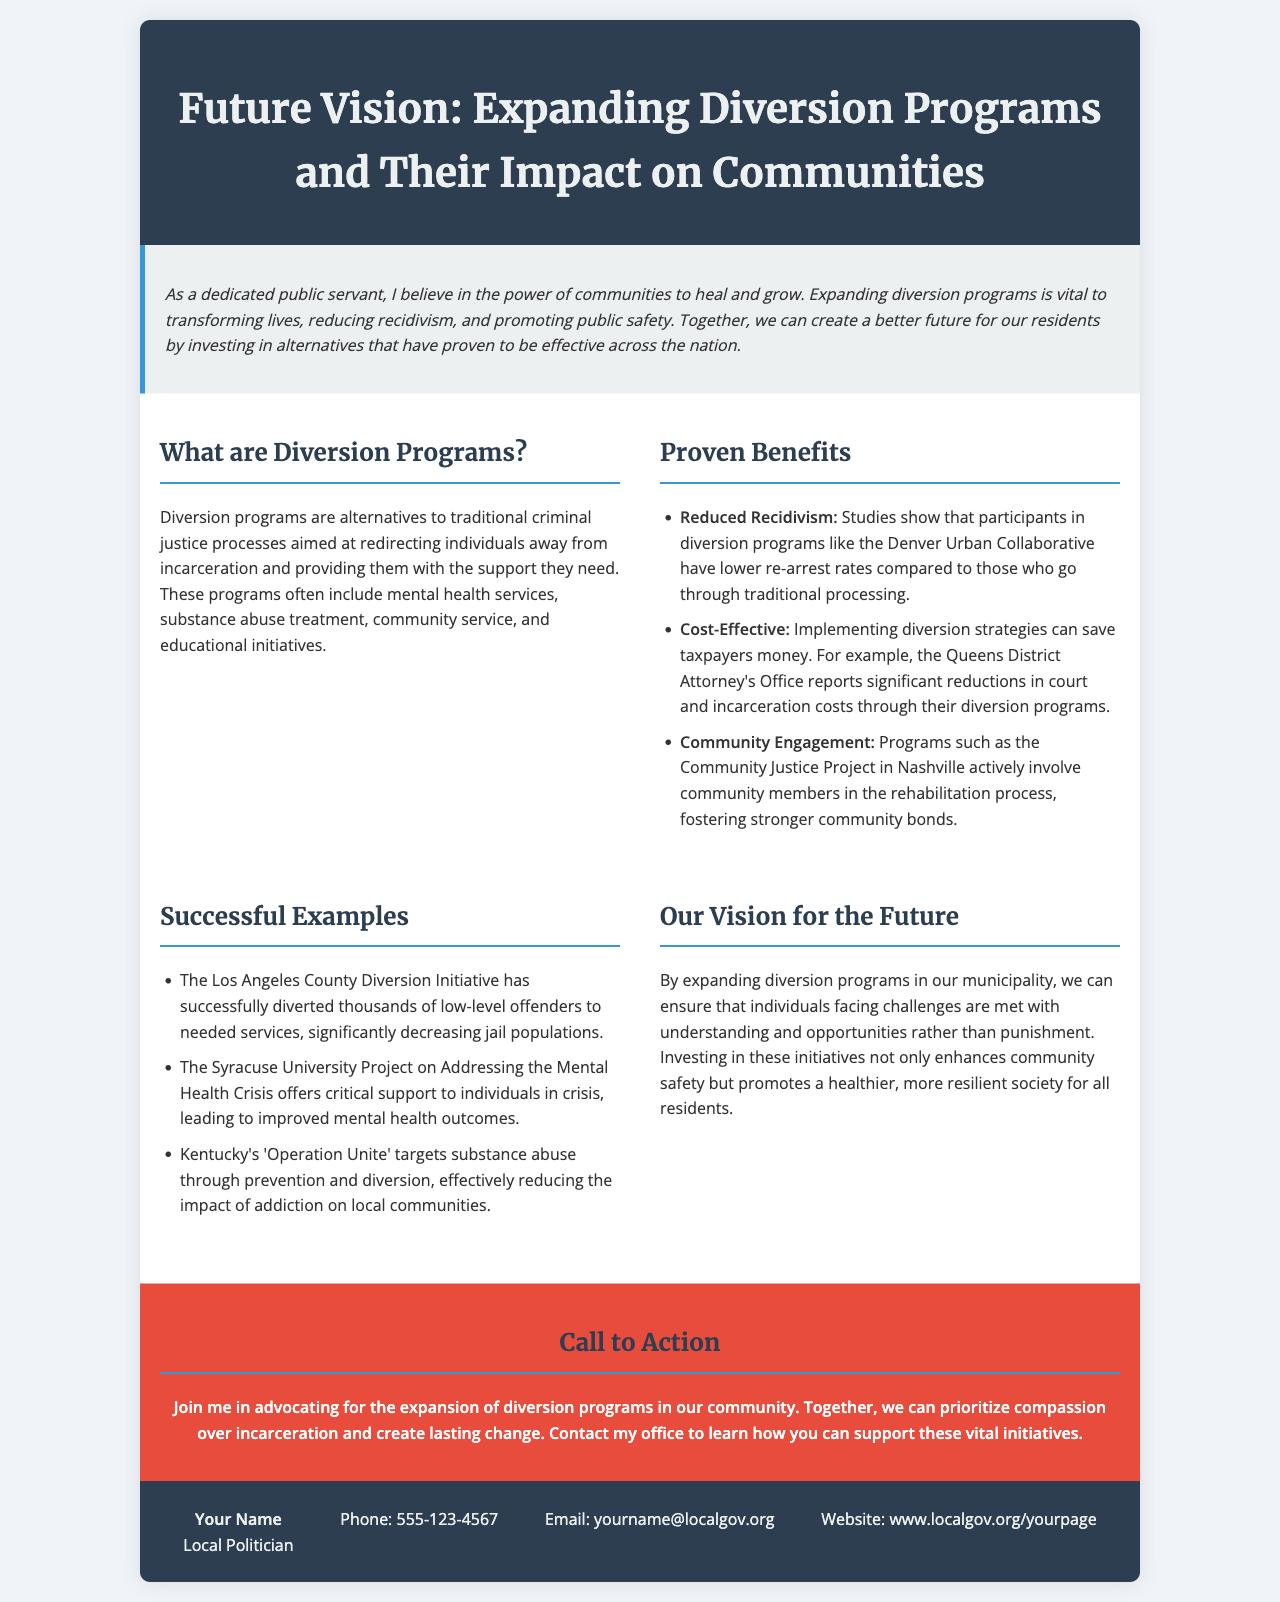What are diversion programs? Diversion programs are alternatives to traditional criminal justice processes aimed at redirecting individuals away from incarceration and providing them with support.
Answer: Alternatives to incarceration What is one proven benefit of diversion programs? One proven benefit of diversion programs mentioned is reduced recidivism, as studies show lower re-arrest rates for participants.
Answer: Reduced recidivism Which initiative successfully diverted low-level offenders? The initiative that successfully diverted low-level offenders is the Los Angeles County Diversion Initiative.
Answer: Los Angeles County Diversion Initiative What organization reports cost savings from diversion programs? The organization that reports significant cost reductions from diversion programs is the Queens District Attorney's Office.
Answer: Queens District Attorney's Office What is the main objective of expanding diversion programs according to the vision presented? The main objective of expanding diversion programs is to meet individuals facing challenges with understanding and opportunities rather than punishment.
Answer: Understanding and opportunities How can community members get involved according to the call to action? Community members can get involved by contacting the office to learn how to support these vital initiatives.
Answer: Contact my office What is the printed contact phone number? The printed contact phone number listed in the brochure is 555-123-4567.
Answer: 555-123-4567 What percentage of community engagement is promoted by the Community Justice Project? The document does not specify a percentage, only states that it fosters stronger community bonds.
Answer: Stronger community bonds What style of font is used for the header? The font used for the header is Merriweather, serif.
Answer: Merriweather, serif 